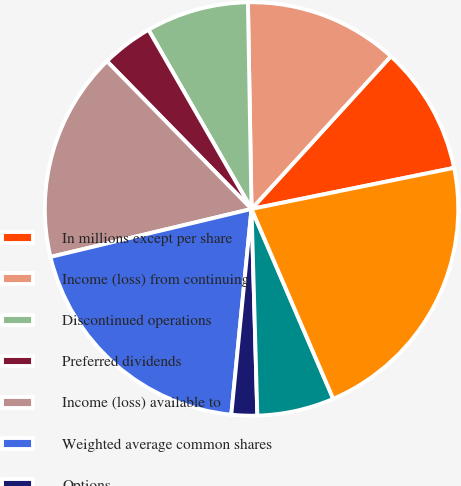Convert chart to OTSL. <chart><loc_0><loc_0><loc_500><loc_500><pie_chart><fcel>In millions except per share<fcel>Income (loss) from continuing<fcel>Discontinued operations<fcel>Preferred dividends<fcel>Income (loss) available to<fcel>Weighted average common shares<fcel>Options<fcel>Restricted and deferred stock<fcel>Adjusted weighted average<nl><fcel>10.04%<fcel>12.05%<fcel>8.03%<fcel>4.02%<fcel>16.4%<fcel>19.71%<fcel>2.01%<fcel>6.02%<fcel>21.72%<nl></chart> 